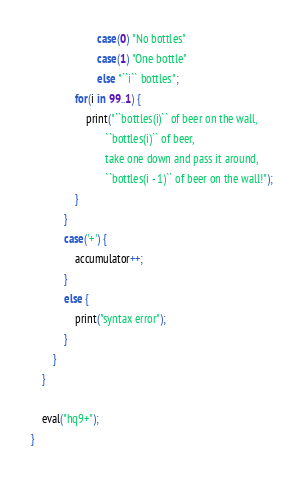Convert code to text. <code><loc_0><loc_0><loc_500><loc_500><_Ceylon_>						case(0) "No bottles"
						case(1) "One bottle"
						else "``i`` bottles";
				for(i in 99..1) {
					print("``bottles(i)`` of beer on the wall,
					       ``bottles(i)`` of beer,
					       take one down and pass it around,
					       ``bottles(i - 1)`` of beer on the wall!");
				}
			}
			case('+') {
				accumulator++;
			}
			else {
				print("syntax error");
			}
		}
	}
	
	eval("hq9+");
}
</code> 